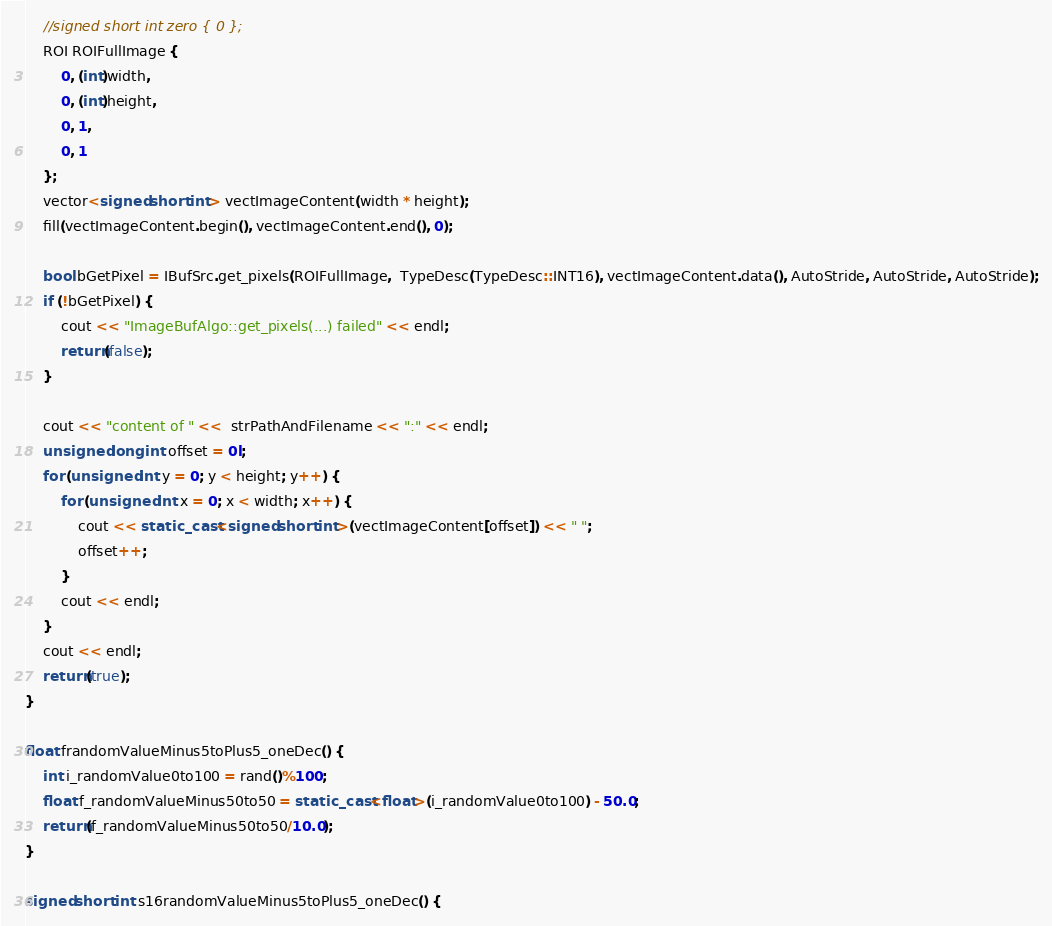<code> <loc_0><loc_0><loc_500><loc_500><_C++_>
    //signed short int zero { 0 };
    ROI ROIFullImage {
        0, (int)width,
        0, (int)height,
        0, 1,
        0, 1
    };
    vector<signed short int> vectImageContent(width * height);
    fill(vectImageContent.begin(), vectImageContent.end(), 0);

    bool bGetPixel = IBufSrc.get_pixels(ROIFullImage,  TypeDesc(TypeDesc::INT16), vectImageContent.data(), AutoStride, AutoStride, AutoStride);
    if (!bGetPixel) {
        cout << "ImageBufAlgo::get_pixels(...) failed" << endl;
        return(false);
    }

    cout << "content of " <<  strPathAndFilename << ":" << endl;
    unsigned long int offset = 0l;
    for (unsigned int y = 0; y < height; y++) {
        for (unsigned int x = 0; x < width; x++) {            
            cout << static_cast<signed short int>(vectImageContent[offset]) << " ";
            offset++;
        }
        cout << endl;
    }
    cout << endl;
    return(true);
}

float frandomValueMinus5toPlus5_oneDec() {
    int i_randomValue0to100 = rand()%100;
    float f_randomValueMinus50to50 = static_cast<float>(i_randomValue0to100) - 50.0;
    return(f_randomValueMinus50to50/10.0);
}

signed short int s16randomValueMinus5toPlus5_oneDec() {</code> 